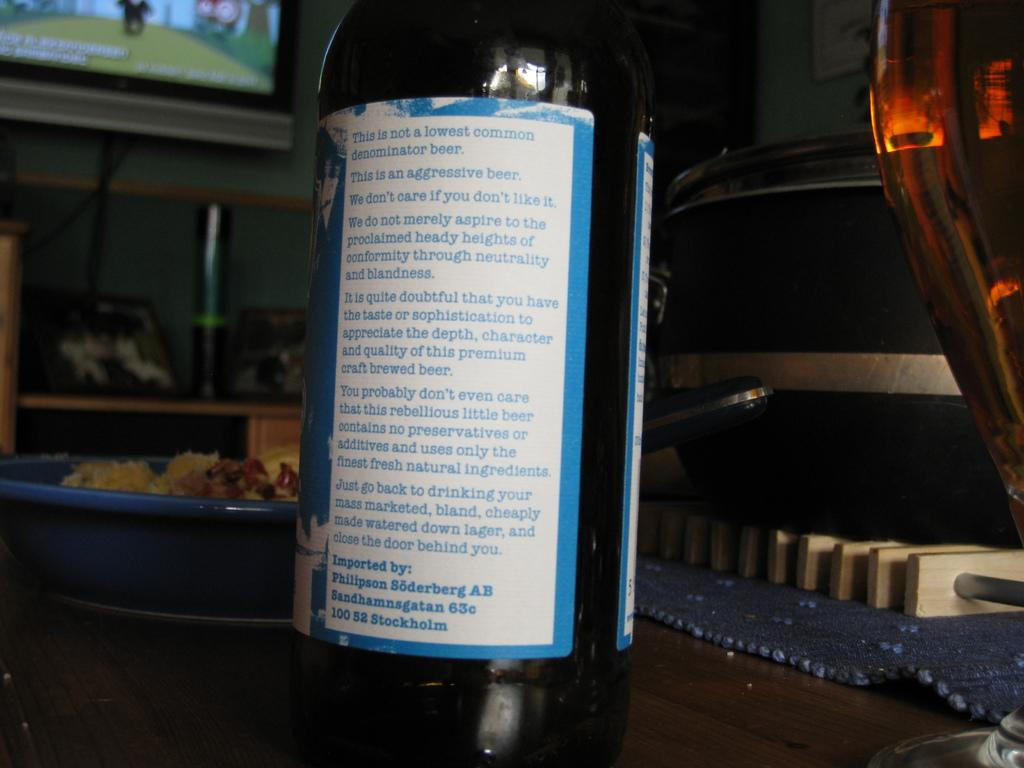<image>
Create a compact narrative representing the image presented. A bottle on a table with a label that says this is an aggressive beer. 